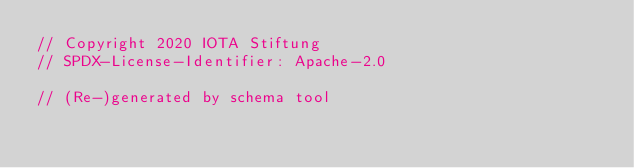Convert code to text. <code><loc_0><loc_0><loc_500><loc_500><_Rust_>// Copyright 2020 IOTA Stiftung
// SPDX-License-Identifier: Apache-2.0

// (Re-)generated by schema tool</code> 